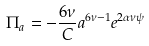<formula> <loc_0><loc_0><loc_500><loc_500>\Pi _ { a } = - \frac { 6 \nu } { C } a ^ { 6 \nu - 1 } e ^ { 2 \alpha \nu \psi }</formula> 